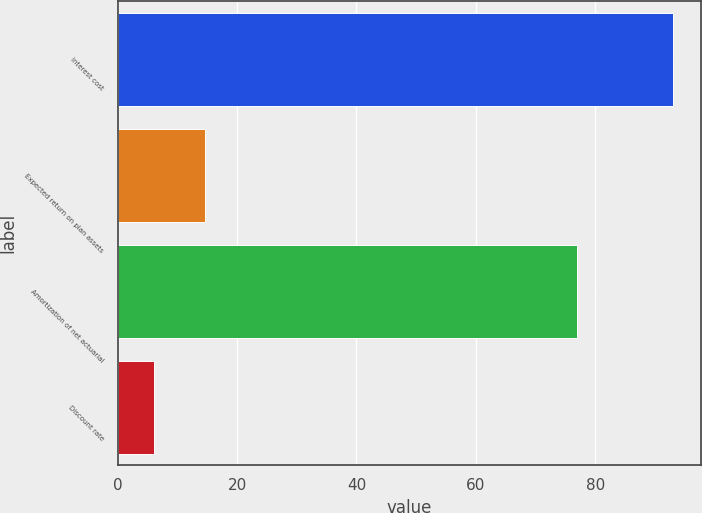Convert chart to OTSL. <chart><loc_0><loc_0><loc_500><loc_500><bar_chart><fcel>Interest cost<fcel>Expected return on plan assets<fcel>Amortization of net actuarial<fcel>Discount rate<nl><fcel>93<fcel>14.7<fcel>77<fcel>6<nl></chart> 